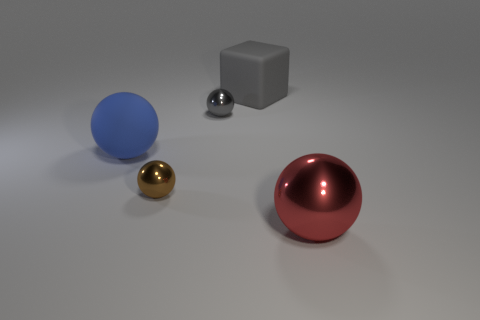Add 1 big red spheres. How many objects exist? 6 Subtract all metallic balls. How many balls are left? 1 Subtract all brown spheres. How many spheres are left? 3 Subtract all cyan blocks. Subtract all yellow cylinders. How many blocks are left? 1 Subtract all tiny metallic objects. Subtract all big red metallic balls. How many objects are left? 2 Add 5 brown metallic spheres. How many brown metallic spheres are left? 6 Add 3 tiny red metal cubes. How many tiny red metal cubes exist? 3 Subtract 0 green cylinders. How many objects are left? 5 Subtract all cubes. How many objects are left? 4 Subtract 3 balls. How many balls are left? 1 